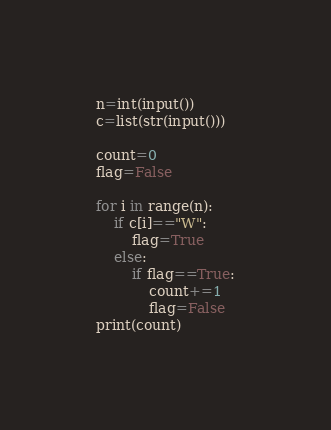Convert code to text. <code><loc_0><loc_0><loc_500><loc_500><_Python_>n=int(input())
c=list(str(input()))

count=0
flag=False

for i in range(n):
	if c[i]=="W":
		flag=True
	else:
		if flag==True:
			count+=1
			flag=False
print(count)</code> 